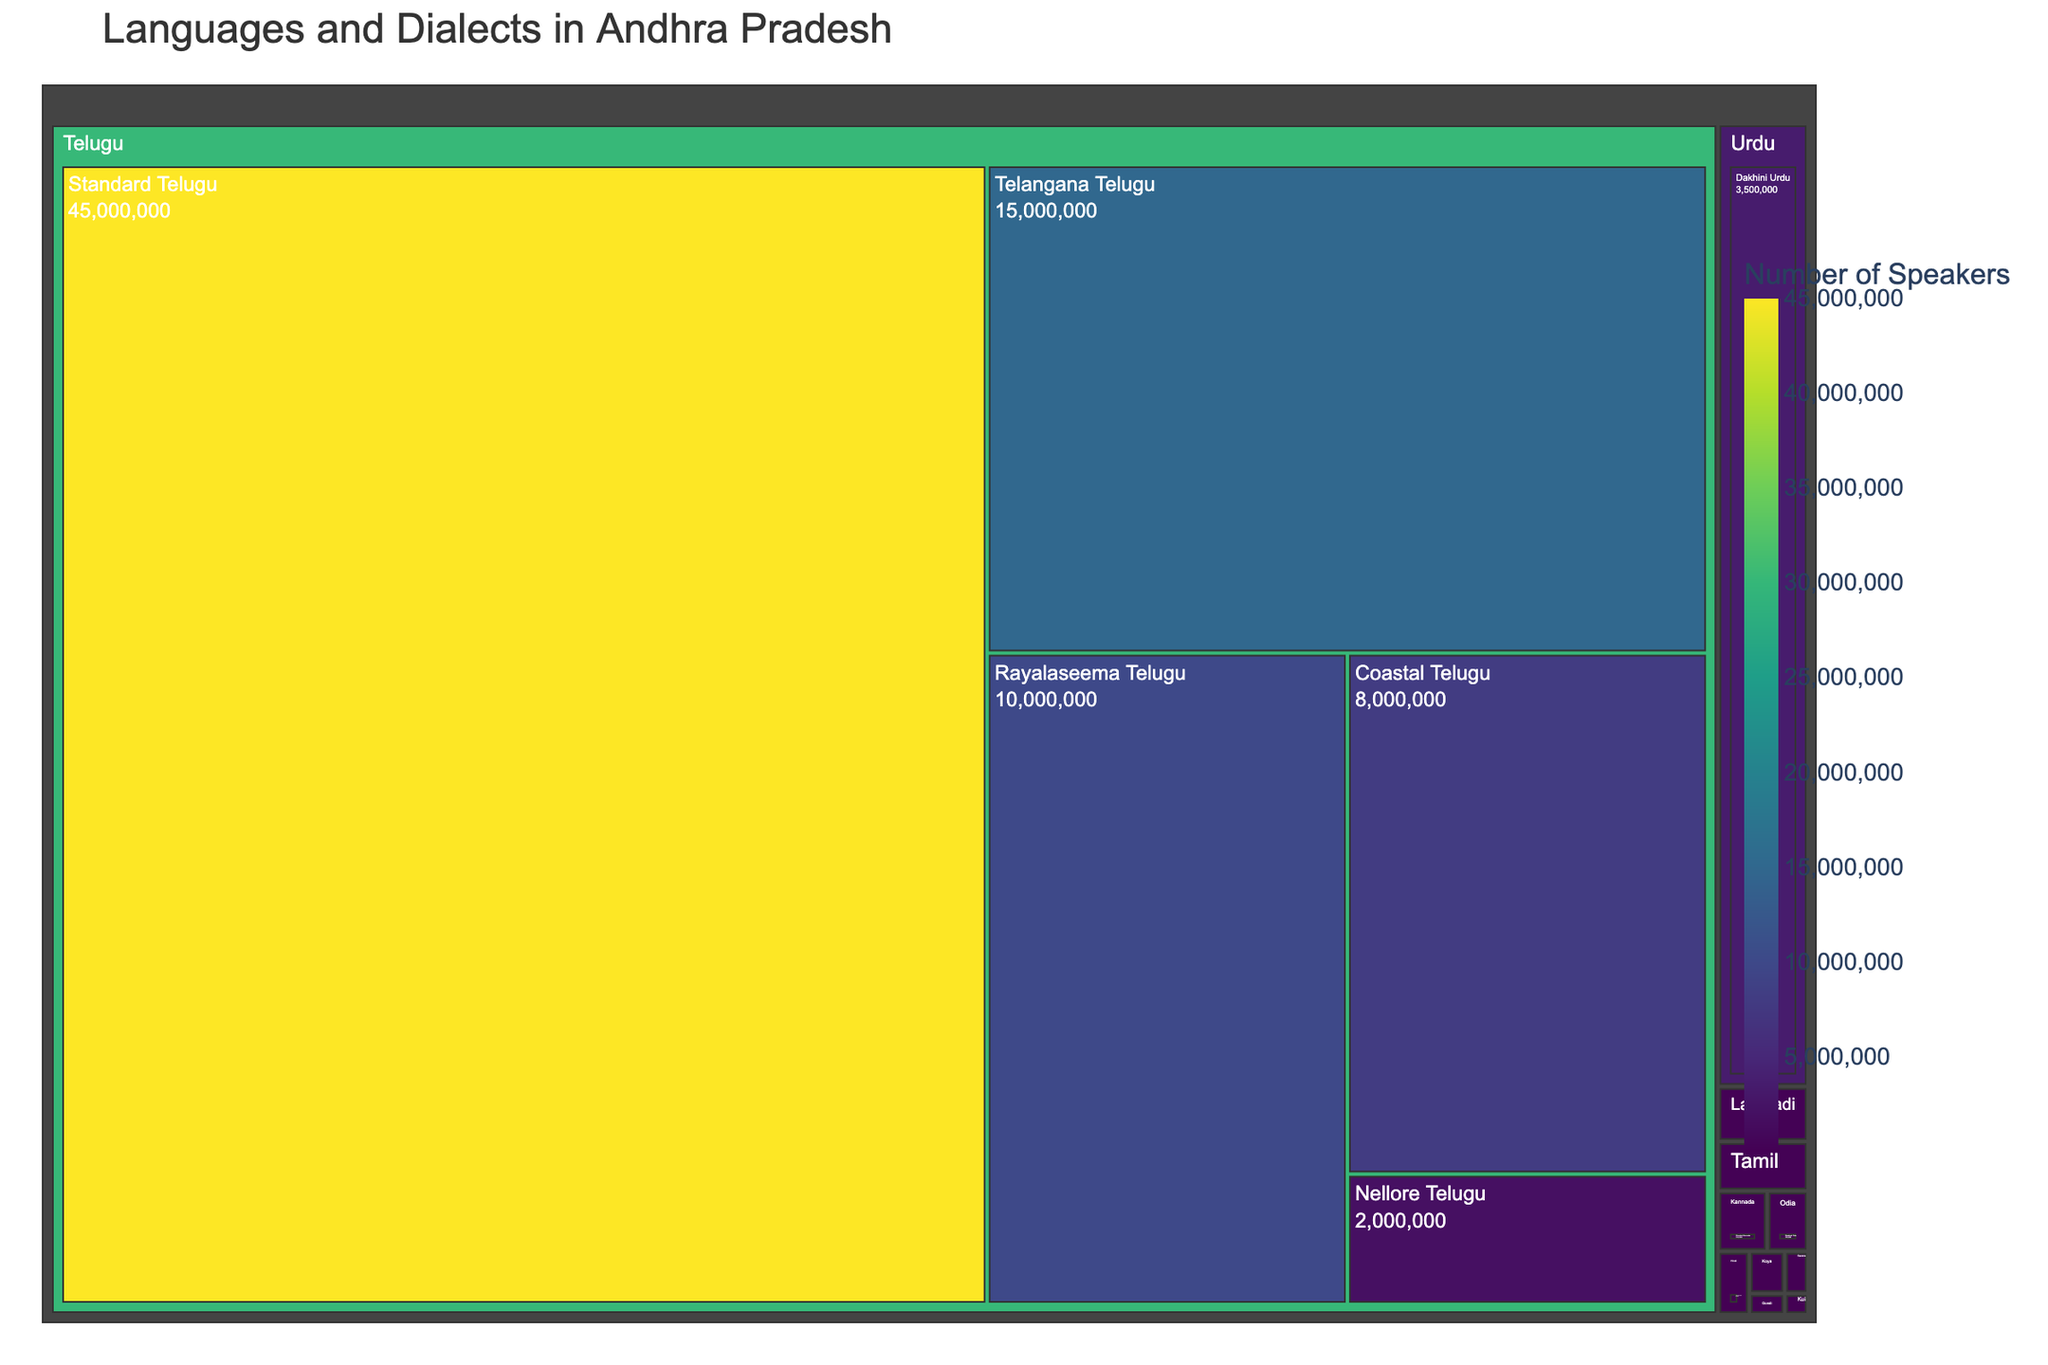What's the title of the figure? The title is usually displayed prominently at the top of the figure. In this case, it is easy to identify the text "Languages and Dialects in Andhra Pradesh" at the top of the Treemap.
Answer: Languages and Dialects in Andhra Pradesh Which language has the highest number of speakers? The largest section of the Treemap represents the Telugu language and its dialects, with "Standard Telugu" having the largest rectangle, indicating the highest number of speakers (45,000,000).
Answer: Telugu (Standard Telugu) How many speakers are there for the dialect Coastal Telugu? Locate the rectangle labeled "Coastal Telugu" under the Telugu language category. The number of speakers is displayed within this rectangle as 8,000,000.
Answer: 8,000,000 Which dialect under the Telugu language has the least number of speakers? Within the Telugu language section, identify the smallest rectangle. The rectangle labeled "Nellore Telugu" is the smallest and has 2,000,000 speakers.
Answer: Nellore Telugu Which non-Telugu dialect has the most speakers? Look at the sections representing languages other than Telugu. The rectangle for "Dakhini Urdu" under Urdu is the largest among non-Telugu dialects, with 3,500,000 speakers.
Answer: Dakhini Urdu How does the number of speakers of Standard Hindi compare to Standard Tamil? Identify the rectangles for both "Standard Hindi" and "Standard Tamil". "Standard Hindi" has 80,000 speakers, while "Standard Tamil" has 180,000 speakers. Thus, Standard Tamil has more speakers than Standard Hindi.
Answer: Standard Tamil has more speakers What's the total number of dialects represented for the Telugu language? Under the Telugu language section, count the number of rectangles that represent different dialects: Standard Telugu, Telangana Telugu, Rayalaseema Telugu, Coastal Telugu, and Nellore Telugu. There are 5 dialects in total.
Answer: 5 What's the total number of speakers for all Telugu dialects combined? Sum the number of speakers for all Telugu dialects: 45,000,000 (Standard Telugu) + 15,000,000 (Telangana Telugu) + 10,000,000 (Rayalaseema Telugu) + 8,000,000 (Coastal Telugu) + 2,000,000 (Nellore Telugu). The total is 80,000,000.
Answer: 80,000,000 Which language has fewer speakers: Kannada or Odia? Identify the rectangles for Kannada and Odia. "Standard Kannada" has 120,000 speakers, while "Standard Odia" has 100,000 speakers. So, Odia has fewer speakers than Kannada.
Answer: Odia Is the number of speakers for Lambadi greater than or less than the speakers for Koya and Savara combined? Find the number of speakers for Lambadi, Koya, and Savara. Lambadi has 200,000 speakers, Koya has 60,000, and Savara has 40,000. Combined, Koya and Savara have 60,000 + 40,000 = 100,000 speakers, which is less than 200,000 speakers for Lambadi.
Answer: Greater 